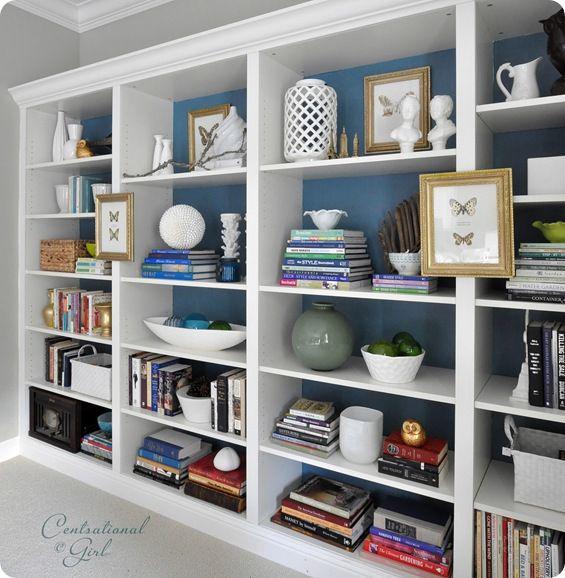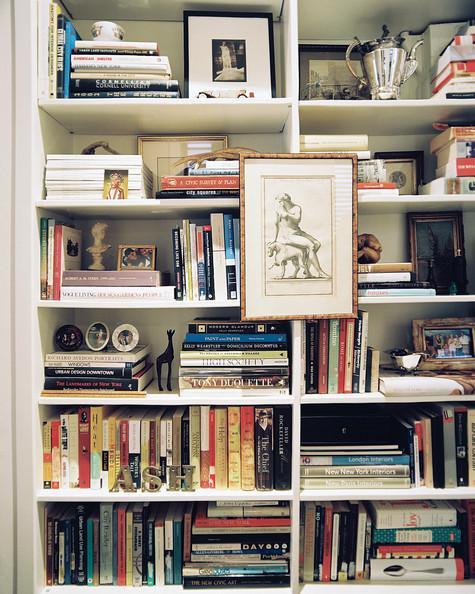The first image is the image on the left, the second image is the image on the right. Analyze the images presented: Is the assertion "In one image, living room couches and coffee table are arranged in front of a large shelving unit." valid? Answer yes or no. No. The first image is the image on the left, the second image is the image on the right. Evaluate the accuracy of this statement regarding the images: "In 1 of the images, the shelves have furniture in front of them.". Is it true? Answer yes or no. No. 